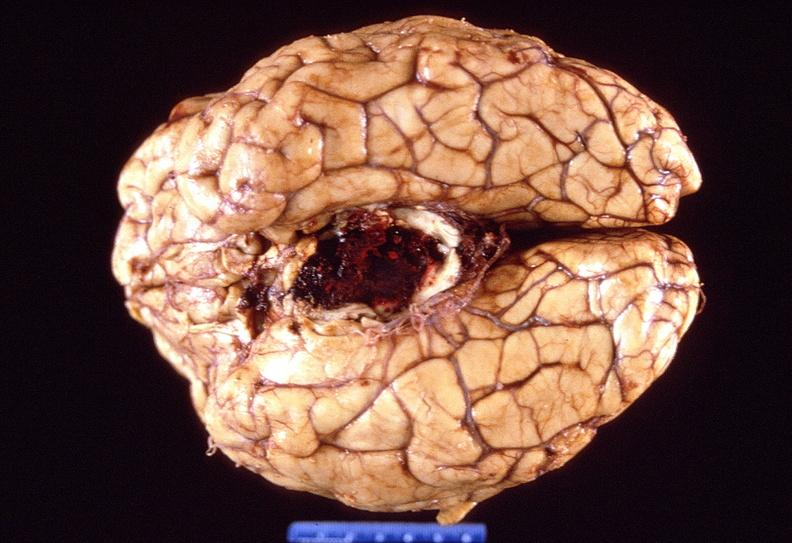s one present?
Answer the question using a single word or phrase. No 